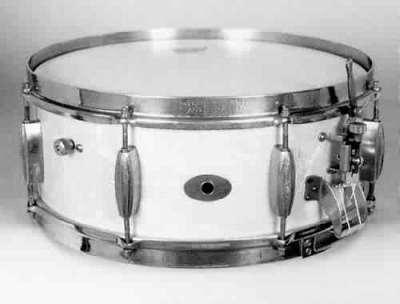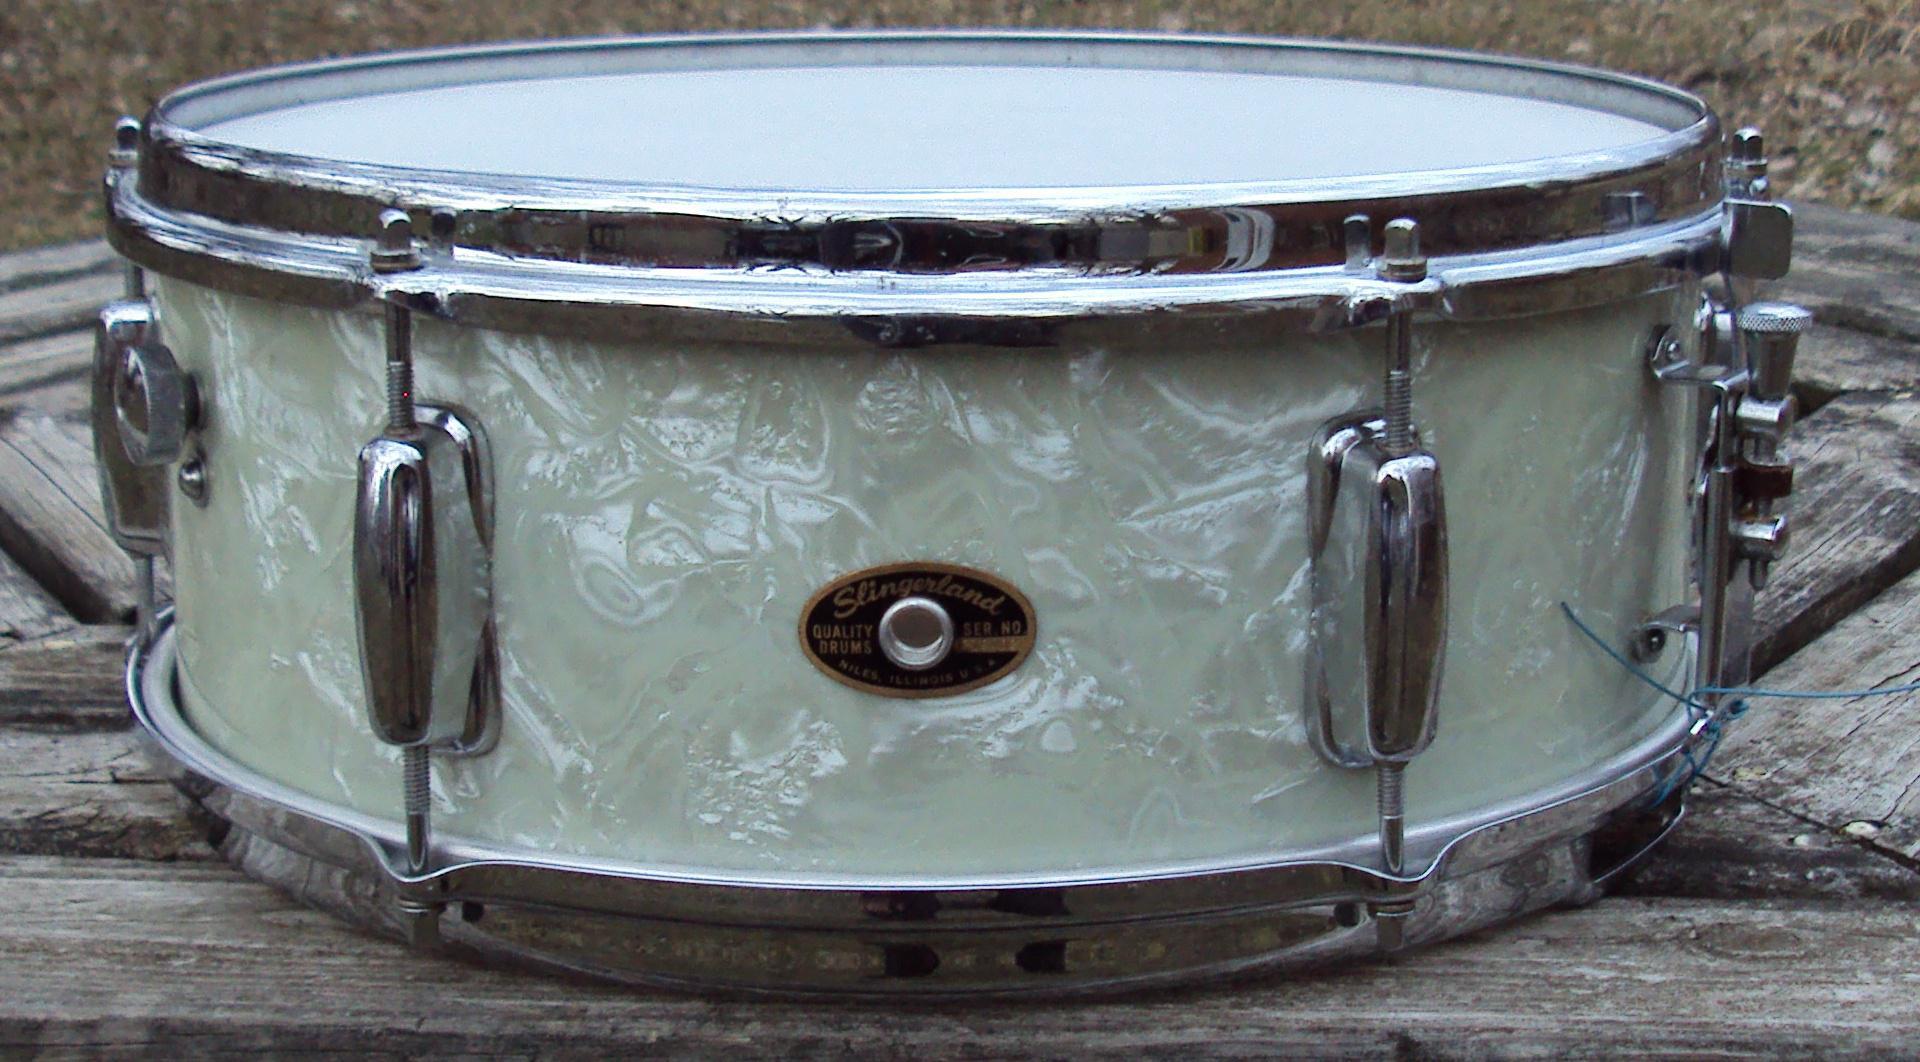The first image is the image on the left, the second image is the image on the right. Evaluate the accuracy of this statement regarding the images: "The drum on the left is white.". Is it true? Answer yes or no. Yes. 